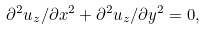Convert formula to latex. <formula><loc_0><loc_0><loc_500><loc_500>\partial ^ { 2 } u _ { z } / \partial x ^ { 2 } + \partial ^ { 2 } u _ { z } / \partial y ^ { 2 } = 0 ,</formula> 